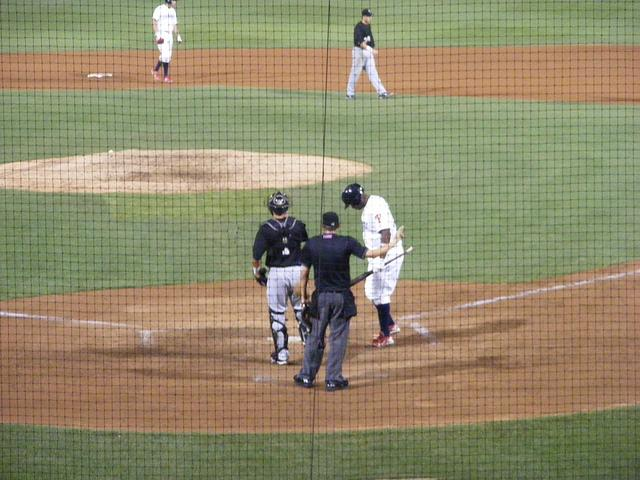Who is wearing the most gear? catcher 